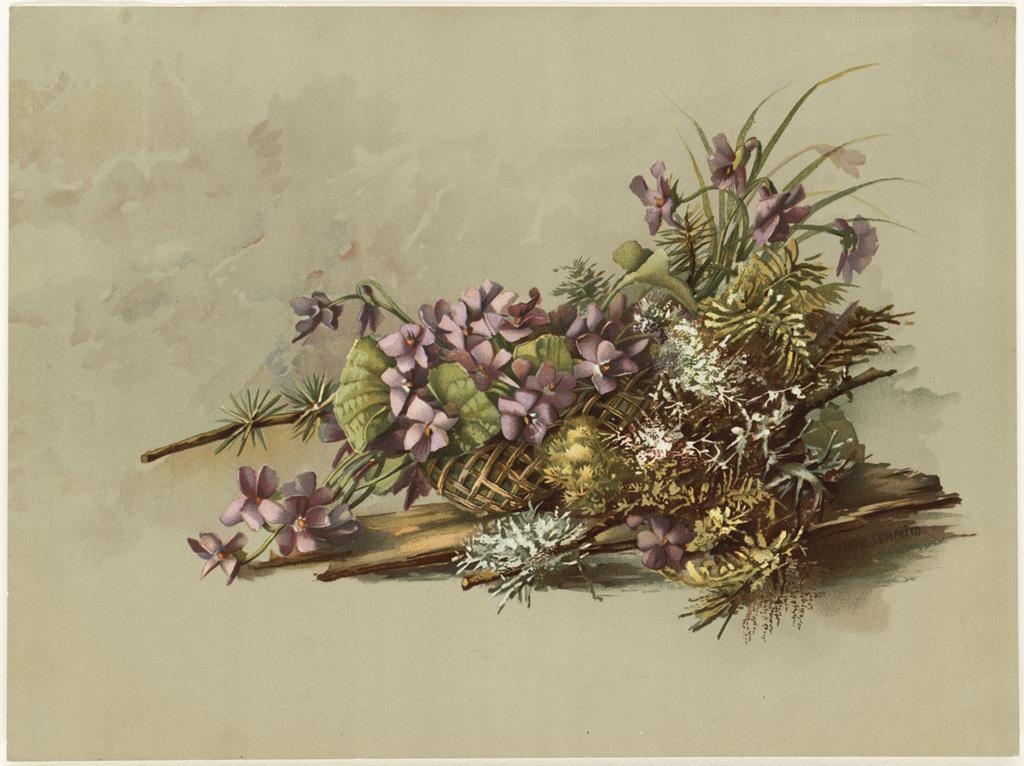Describe this image in one or two sentences. In this image we can see the picture of bunch of flowers on a paper. 